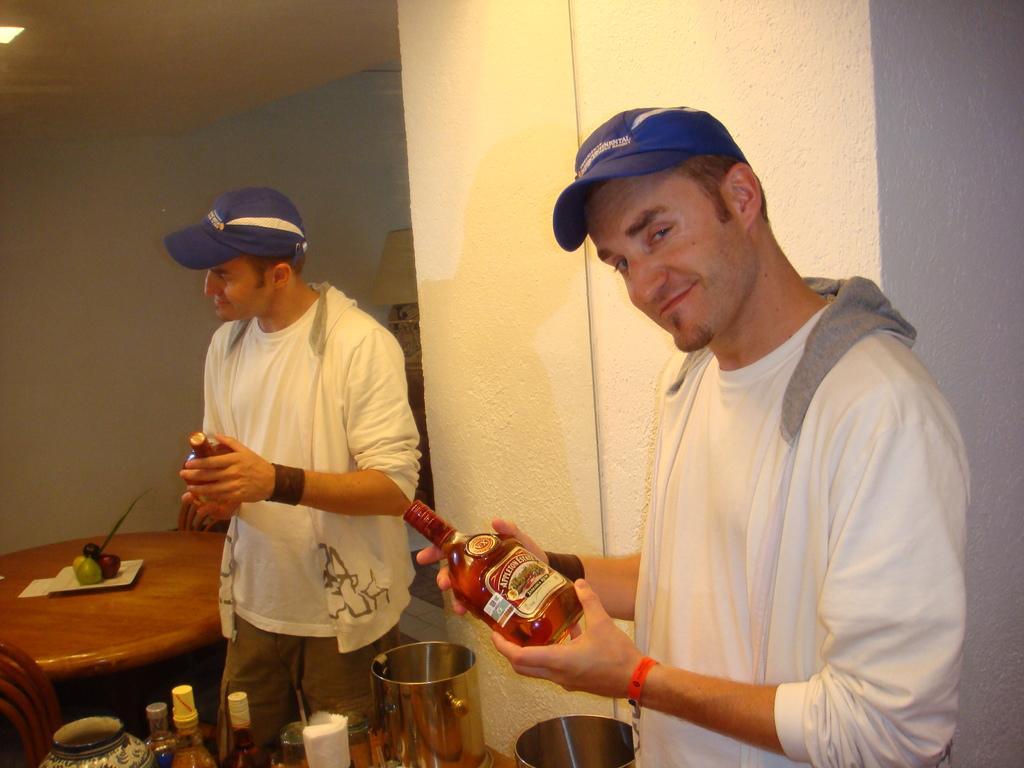Could you give a brief overview of what you see in this image? In this image we can see a man wearing the cap and also holding the alcohol bottle and standing. We can also see the steel vessel, wall and also the mirror and through the mirror we can see the reflection of a person wearing the cap and also holding the bottle. We can also see the dining table with the chairs and on the table we can see the fruits. We can also see the alcohol bottles and some other objects. We can see the wall and also the light and the ceiling. 